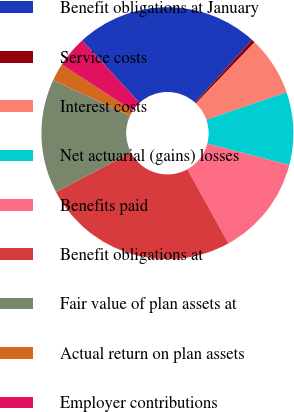<chart> <loc_0><loc_0><loc_500><loc_500><pie_chart><fcel>Benefit obligations at January<fcel>Service costs<fcel>Interest costs<fcel>Net actuarial (gains) losses<fcel>Benefits paid<fcel>Benefit obligations at<fcel>Fair value of plan assets at<fcel>Actual return on plan assets<fcel>Employer contributions<nl><fcel>23.53%<fcel>0.47%<fcel>7.56%<fcel>9.34%<fcel>12.89%<fcel>25.3%<fcel>14.66%<fcel>2.24%<fcel>4.01%<nl></chart> 